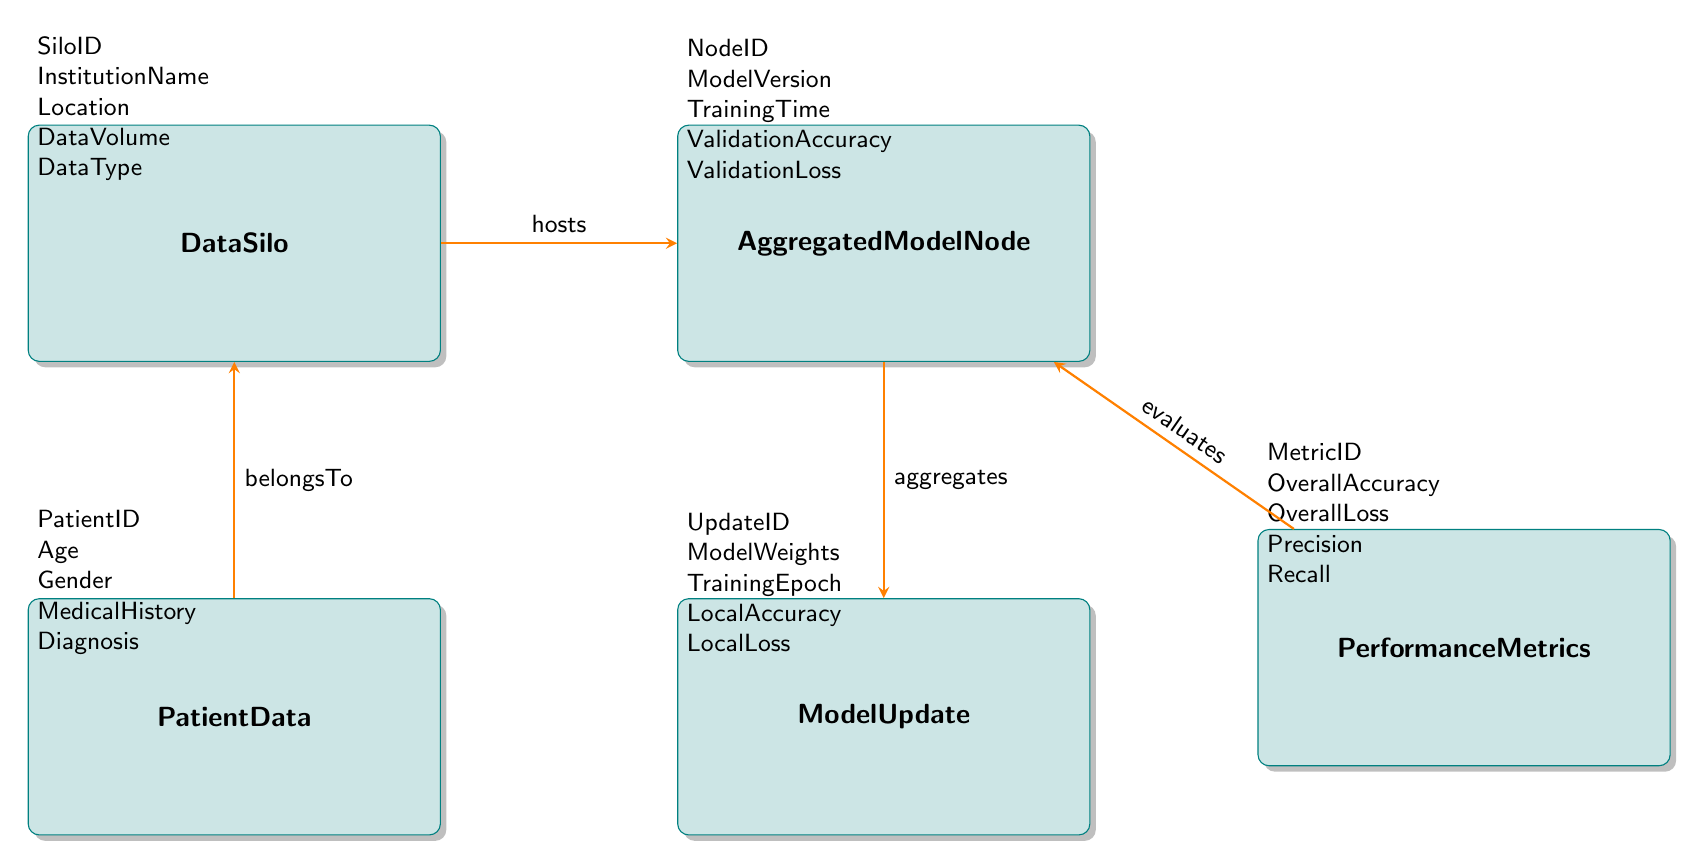What are the attributes of DataSilo? The attributes for the DataSilo entity listed in the diagram are SiloID, InstitutionName, Location, DataVolume, and DataType. Each attribute is explicitly presented beneath the DataSilo entity in the diagram.
Answer: SiloID, InstitutionName, Location, DataVolume, DataType How many entities are in the diagram? By counting the individual entities represented in the diagram – DataSilo, PatientData, AggregatedModelNode, ModelUpdate, and PerformanceMetrics – we find there are a total of five entities.
Answer: 5 What relationship exists between DataSilo and AggregatedModelNode? The diagram shows that DataSilo hosts AggregatedModelNode, indicating a direct association where DataSilo actively supports or contains the AggregatedModelNode entity.
Answer: hosts Which entity does PatientData belong to? According to the diagram, PatientData belongs to DataSilo. This indicates that each patient’s data is stored within a specific data silo.
Answer: DataSilo What attributes does AggregatedModelNode have? The AggregatedModelNode entity's attributes are presented in the diagram as NodeID, ModelVersion, TrainingTime, ValidationAccuracy, and ValidationLoss, detailing the characteristics of the aggregated model node.
Answer: NodeID, ModelVersion, TrainingTime, ValidationAccuracy, ValidationLoss What does PerformanceMetrics evaluate? PerformanceMetrics is shown to evaluate AggregatedModelNode based on the relationship noted in the diagram, meaning that the performance metrics relate to or assess the aggregated model node's performance.
Answer: AggregatedModelNode How does the ModelUpdate relate to AggregatedModelNode? The model update is indicated in the diagram as aggregating to the AggregatedModelNode, which means that updates to the model weights and other aspects contribute to the aggregated model node's characteristics.
Answer: aggregates What is the update relationship for ModelUpdate? The relationship for ModelUpdate is not specifically defined as it pertains to another entity, but it focuses on the aggregation aspect which is complementary to its connection with AggregatedModelNode.
Answer: None 